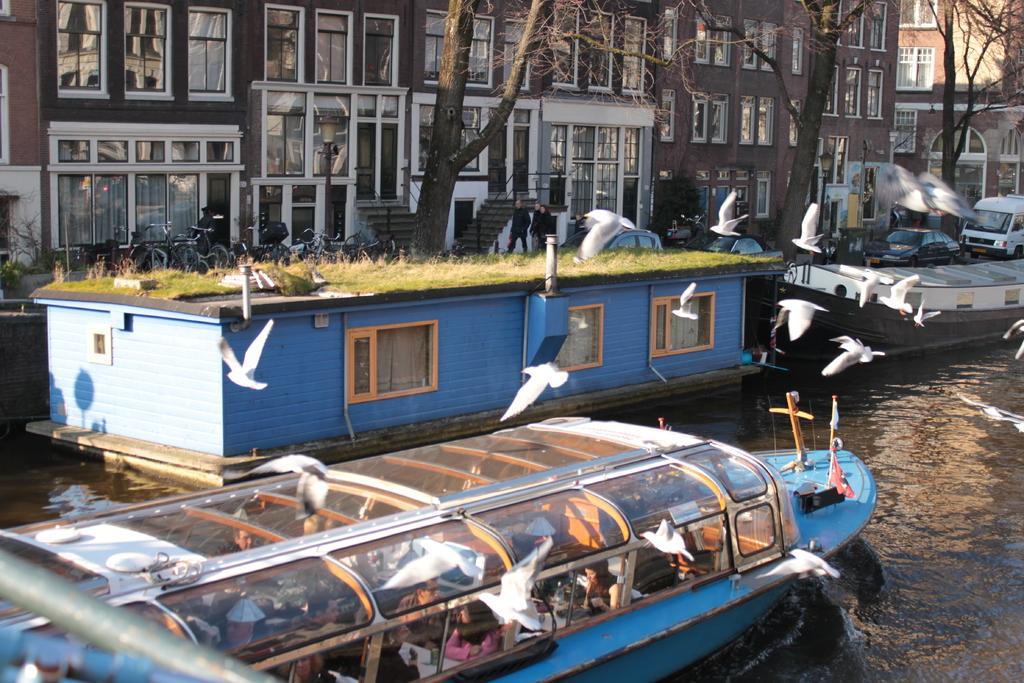Could you give a brief overview of what you see in this image? As we can see in the image there is grass, white color boats, water, buildings, trees and boats. 